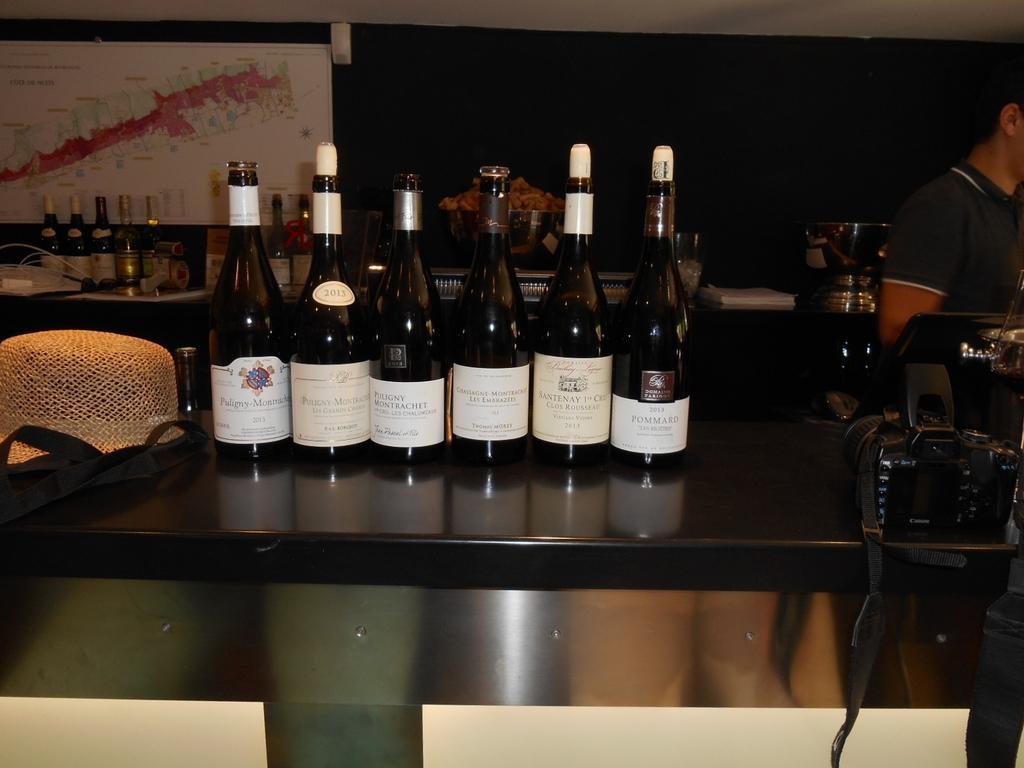In one or two sentences, can you explain what this image depicts? In this picture there is a table. On the table there are six bottles. And to the table right corner there is a camera. Behind the table there is a man standing to the right corner. And behind him there is a wall in black color. And to the left top corner there is a map. We can see more bottle to the left corner on the table. 